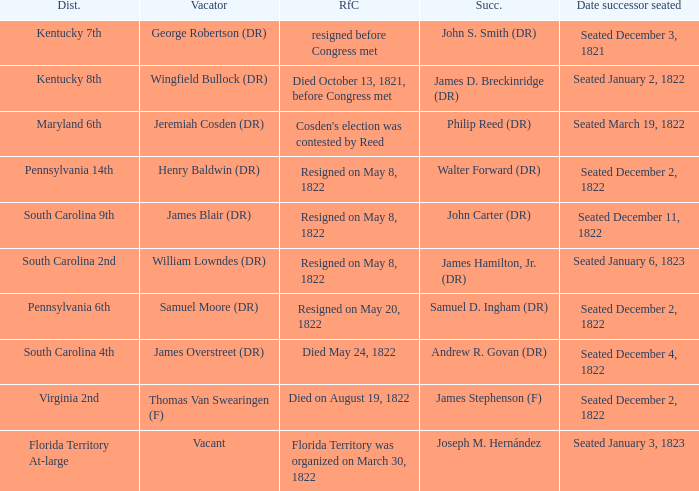Who is the successor when florida territory at-large is the district? Joseph M. Hernández. 